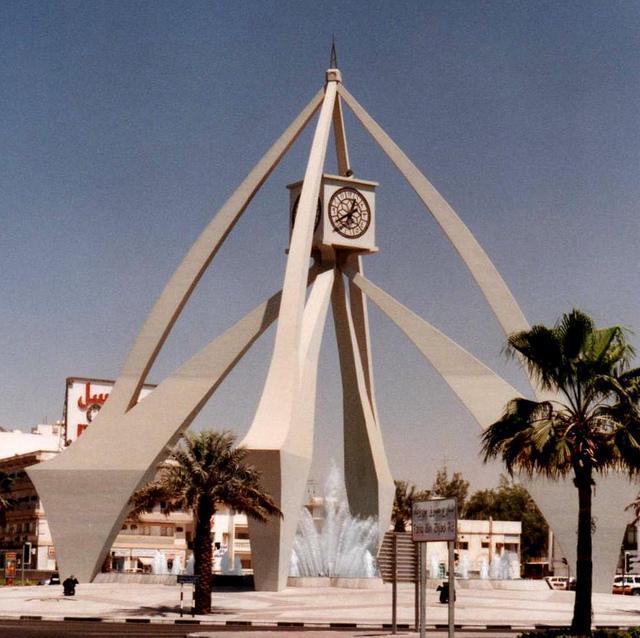How many bicycles are in this picture?
Give a very brief answer. 0. 